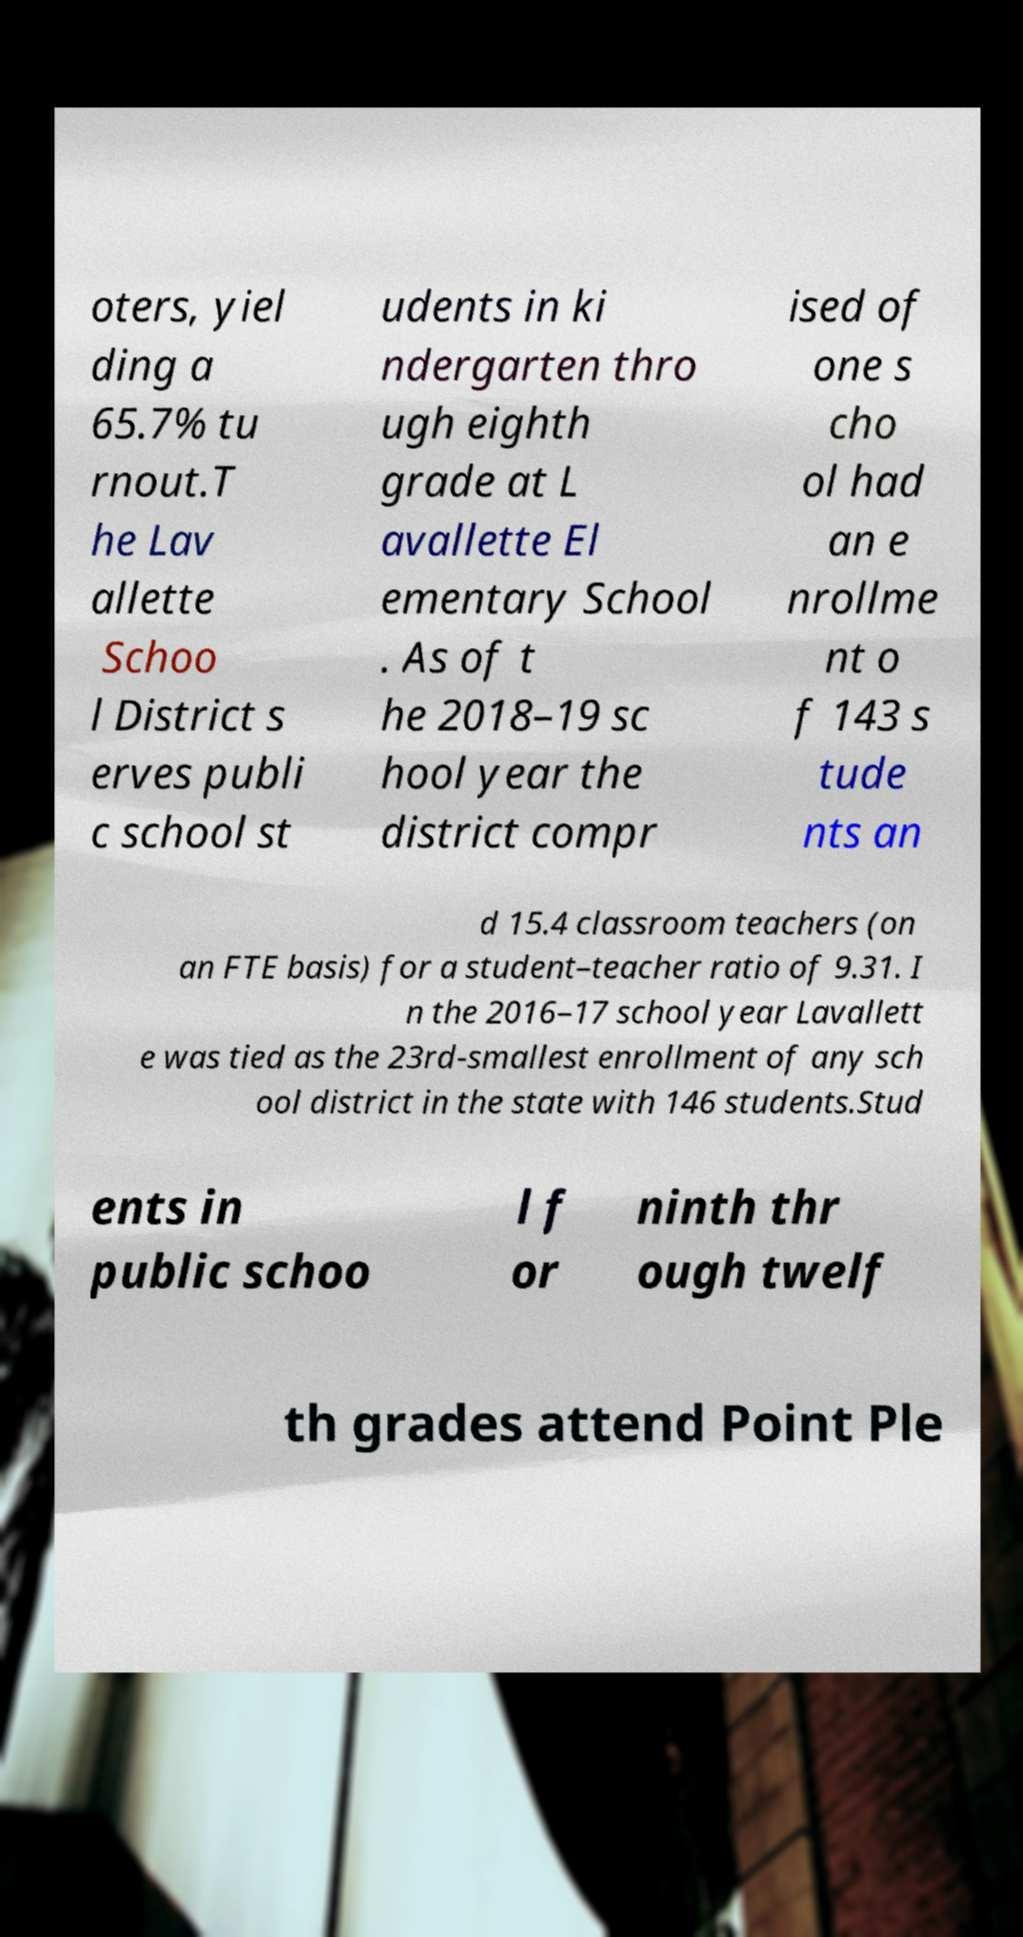Can you read and provide the text displayed in the image?This photo seems to have some interesting text. Can you extract and type it out for me? oters, yiel ding a 65.7% tu rnout.T he Lav allette Schoo l District s erves publi c school st udents in ki ndergarten thro ugh eighth grade at L avallette El ementary School . As of t he 2018–19 sc hool year the district compr ised of one s cho ol had an e nrollme nt o f 143 s tude nts an d 15.4 classroom teachers (on an FTE basis) for a student–teacher ratio of 9.31. I n the 2016–17 school year Lavallett e was tied as the 23rd-smallest enrollment of any sch ool district in the state with 146 students.Stud ents in public schoo l f or ninth thr ough twelf th grades attend Point Ple 